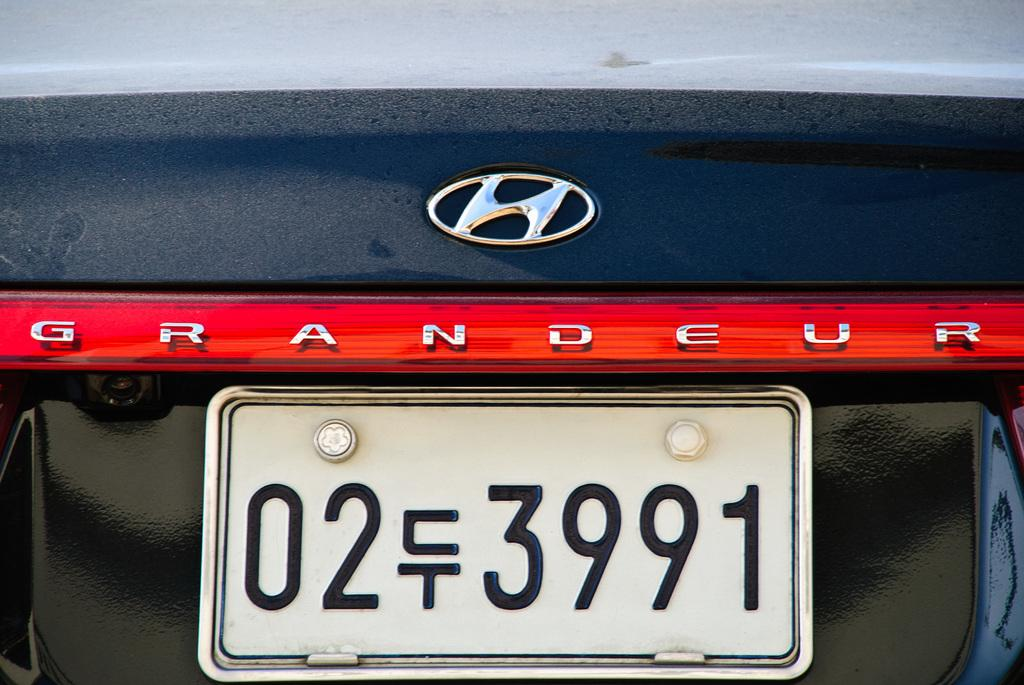<image>
Provide a brief description of the given image. White license plate which says 3991 on it. 